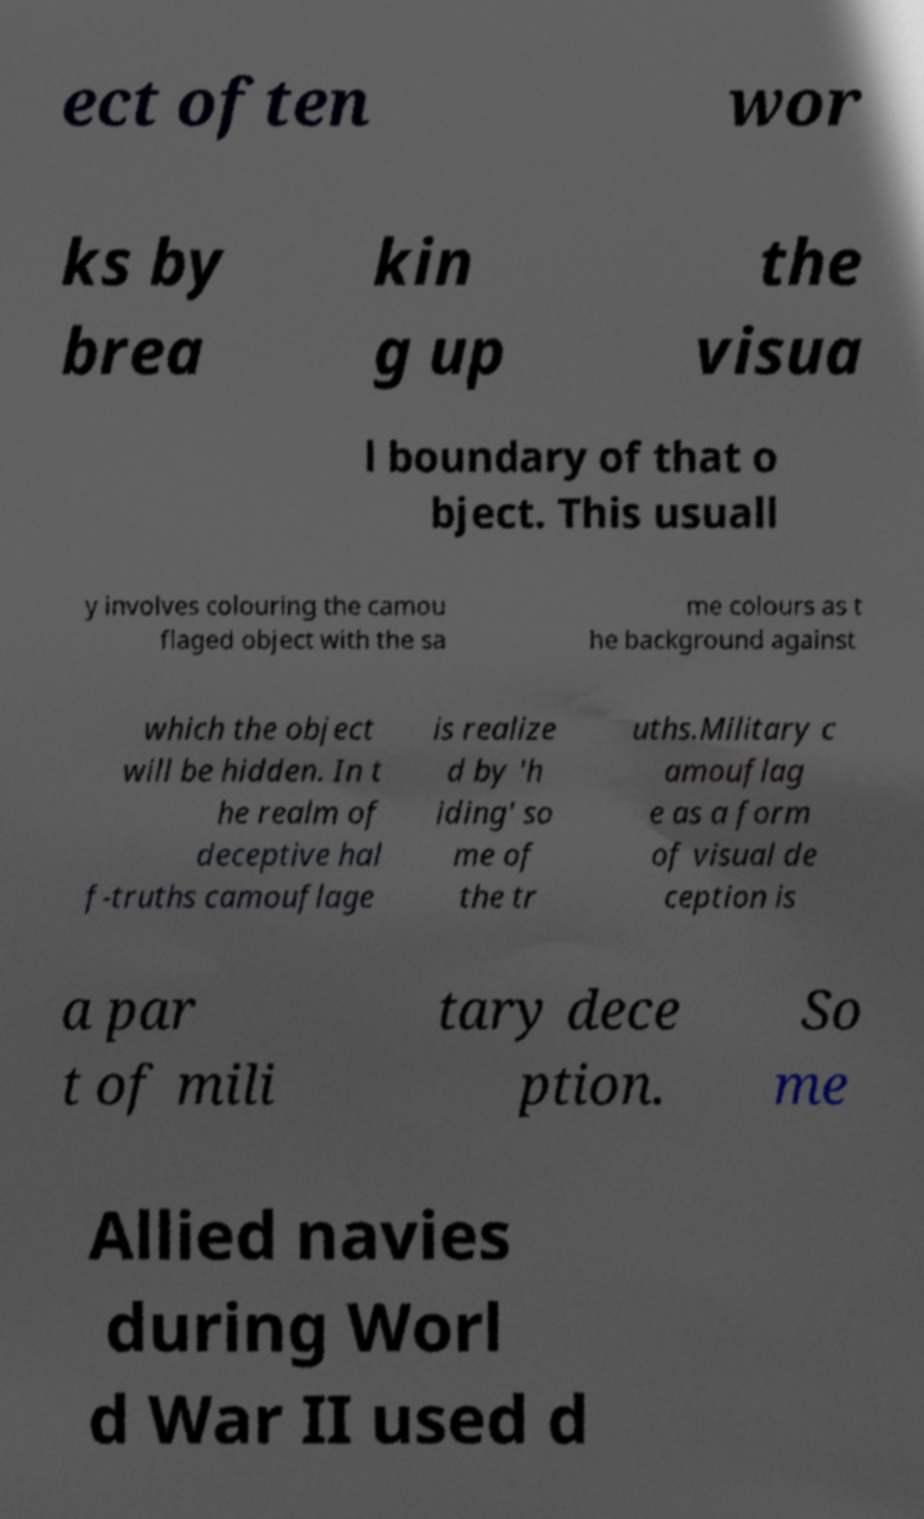Could you extract and type out the text from this image? ect often wor ks by brea kin g up the visua l boundary of that o bject. This usuall y involves colouring the camou flaged object with the sa me colours as t he background against which the object will be hidden. In t he realm of deceptive hal f-truths camouflage is realize d by 'h iding' so me of the tr uths.Military c amouflag e as a form of visual de ception is a par t of mili tary dece ption. So me Allied navies during Worl d War II used d 